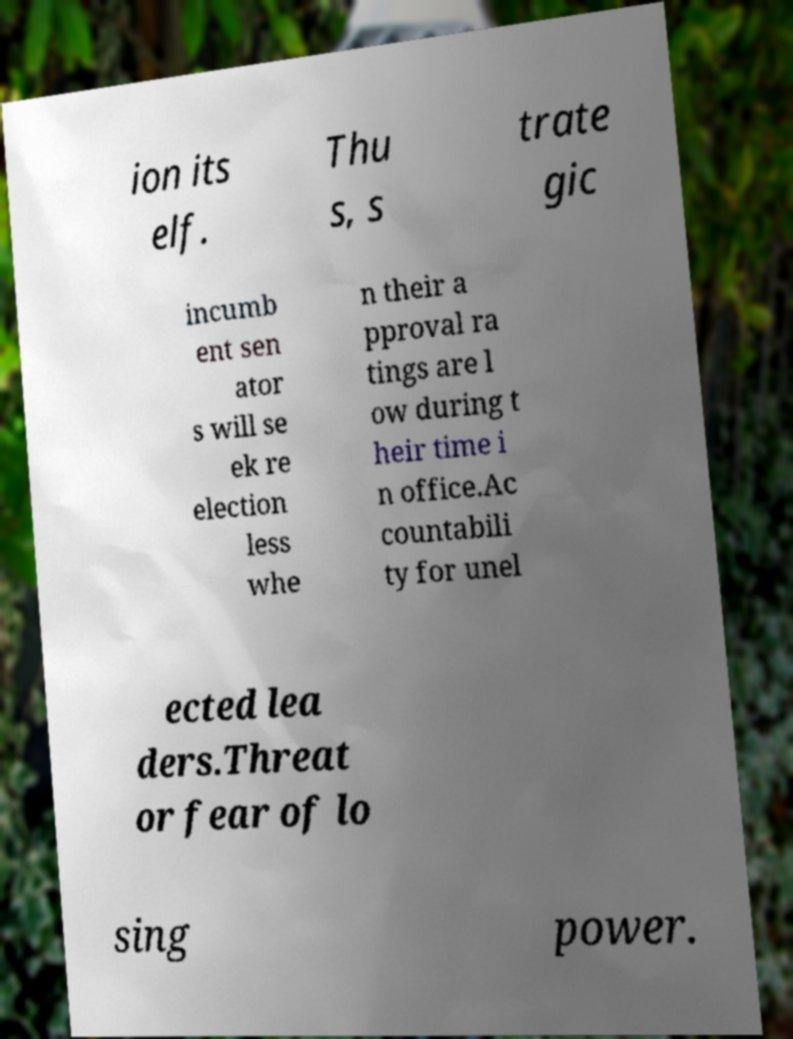Could you assist in decoding the text presented in this image and type it out clearly? ion its elf. Thu s, s trate gic incumb ent sen ator s will se ek re election less whe n their a pproval ra tings are l ow during t heir time i n office.Ac countabili ty for unel ected lea ders.Threat or fear of lo sing power. 